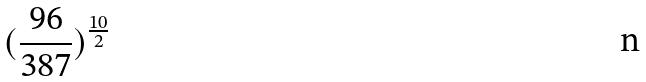Convert formula to latex. <formula><loc_0><loc_0><loc_500><loc_500>( \frac { 9 6 } { 3 8 7 } ) ^ { \frac { 1 0 } { 2 } }</formula> 